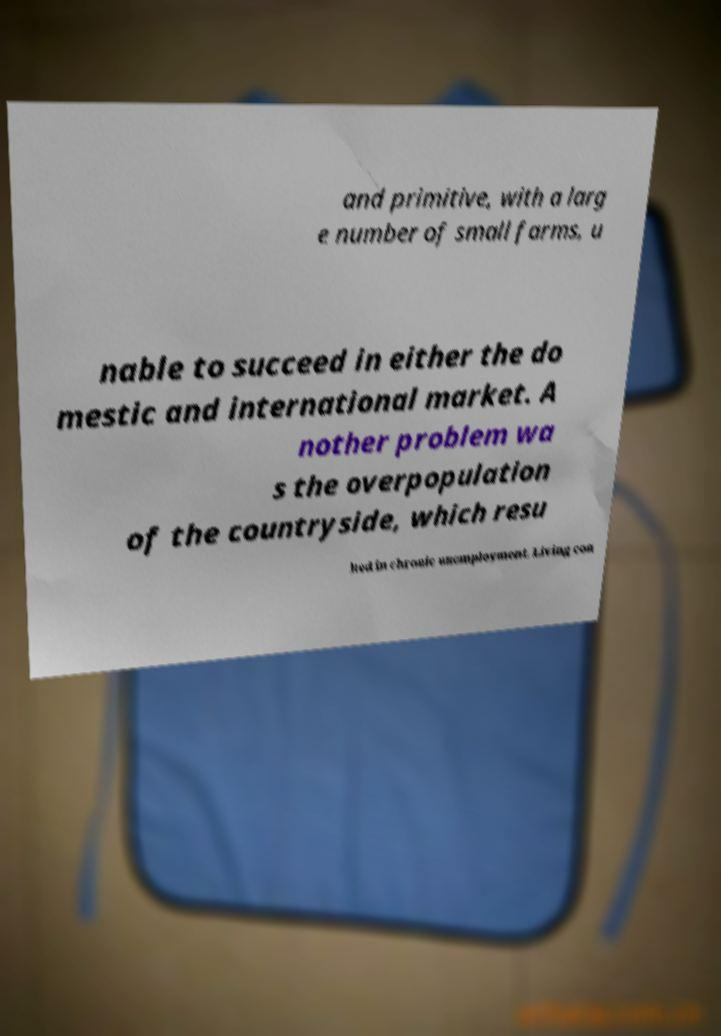Can you read and provide the text displayed in the image?This photo seems to have some interesting text. Can you extract and type it out for me? and primitive, with a larg e number of small farms, u nable to succeed in either the do mestic and international market. A nother problem wa s the overpopulation of the countryside, which resu lted in chronic unemployment. Living con 